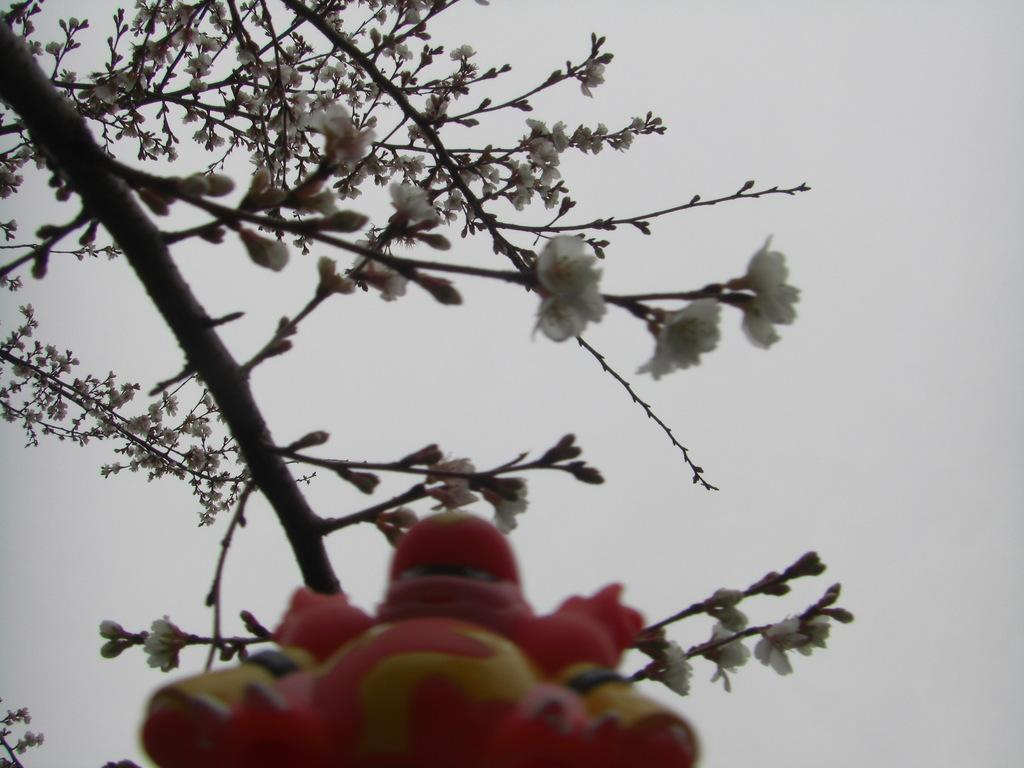What type of tree is in the image? There is a cherry blossom tree in the image. What other object can be seen at the bottom of the image? There is a toy at the bottom of the image. What can be seen in the background of the image? The sky is visible in the background of the image. What religion is being practiced by the writer in the image? There is no writer present in the image, and therefore no religious practice can be observed. 